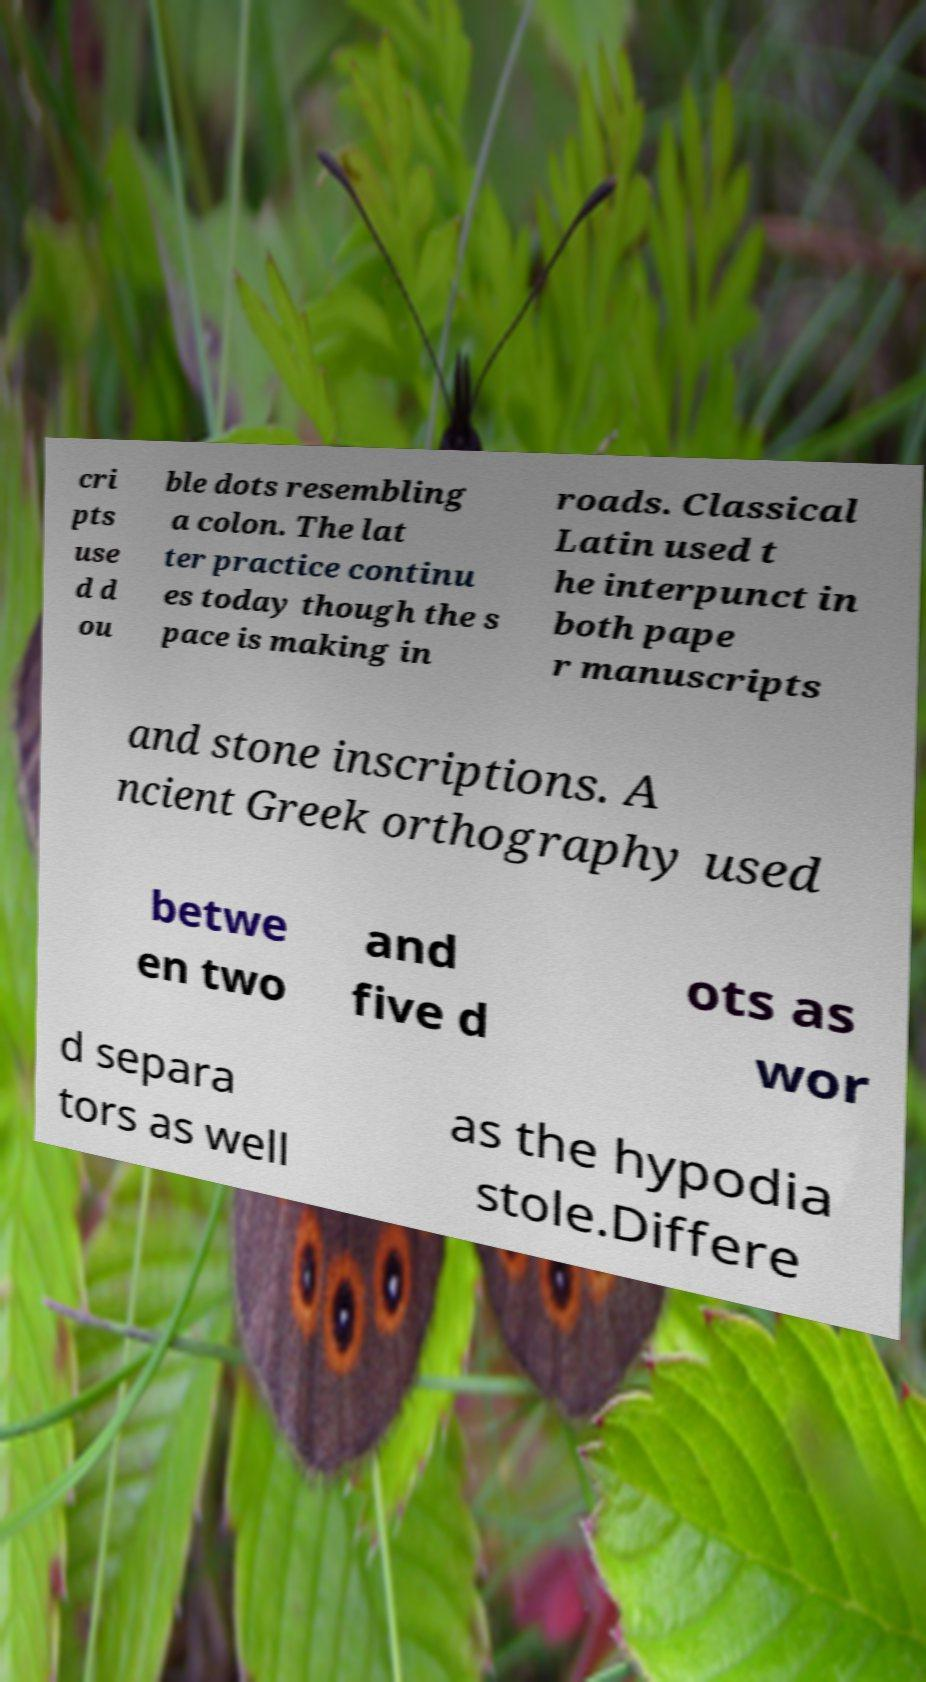For documentation purposes, I need the text within this image transcribed. Could you provide that? cri pts use d d ou ble dots resembling a colon. The lat ter practice continu es today though the s pace is making in roads. Classical Latin used t he interpunct in both pape r manuscripts and stone inscriptions. A ncient Greek orthography used betwe en two and five d ots as wor d separa tors as well as the hypodia stole.Differe 